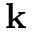<formula> <loc_0><loc_0><loc_500><loc_500>k</formula> 